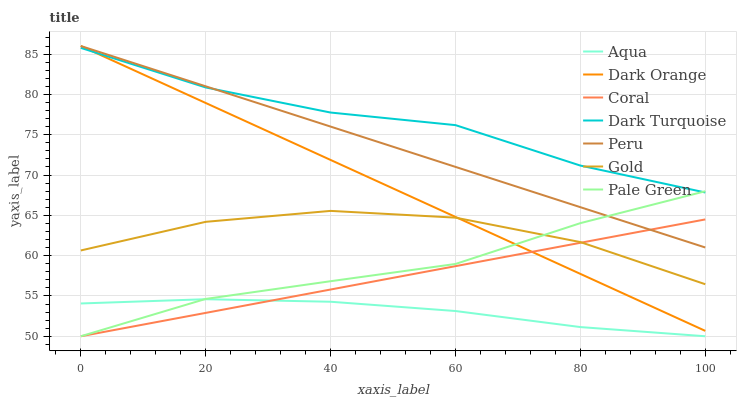Does Aqua have the minimum area under the curve?
Answer yes or no. Yes. Does Dark Turquoise have the maximum area under the curve?
Answer yes or no. Yes. Does Gold have the minimum area under the curve?
Answer yes or no. No. Does Gold have the maximum area under the curve?
Answer yes or no. No. Is Coral the smoothest?
Answer yes or no. Yes. Is Gold the roughest?
Answer yes or no. Yes. Is Dark Turquoise the smoothest?
Answer yes or no. No. Is Dark Turquoise the roughest?
Answer yes or no. No. Does Coral have the lowest value?
Answer yes or no. Yes. Does Gold have the lowest value?
Answer yes or no. No. Does Peru have the highest value?
Answer yes or no. Yes. Does Gold have the highest value?
Answer yes or no. No. Is Gold less than Peru?
Answer yes or no. Yes. Is Dark Turquoise greater than Aqua?
Answer yes or no. Yes. Does Coral intersect Aqua?
Answer yes or no. Yes. Is Coral less than Aqua?
Answer yes or no. No. Is Coral greater than Aqua?
Answer yes or no. No. Does Gold intersect Peru?
Answer yes or no. No. 